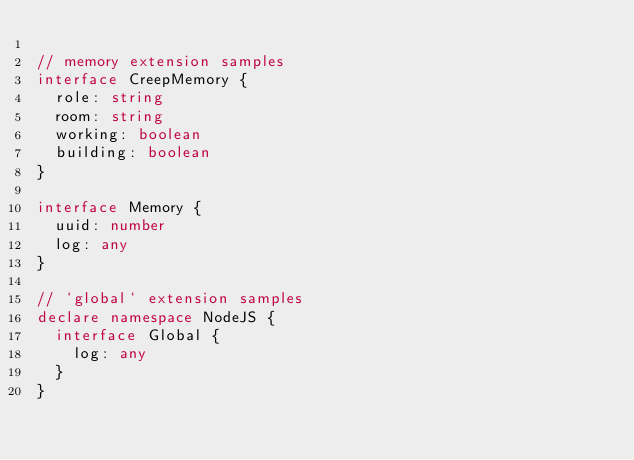Convert code to text. <code><loc_0><loc_0><loc_500><loc_500><_TypeScript_>
// memory extension samples
interface CreepMemory {
  role: string
  room: string
  working: boolean
  building: boolean
}

interface Memory {
  uuid: number
  log: any
}

// `global` extension samples
declare namespace NodeJS {
  interface Global {
    log: any
  }
}
</code> 